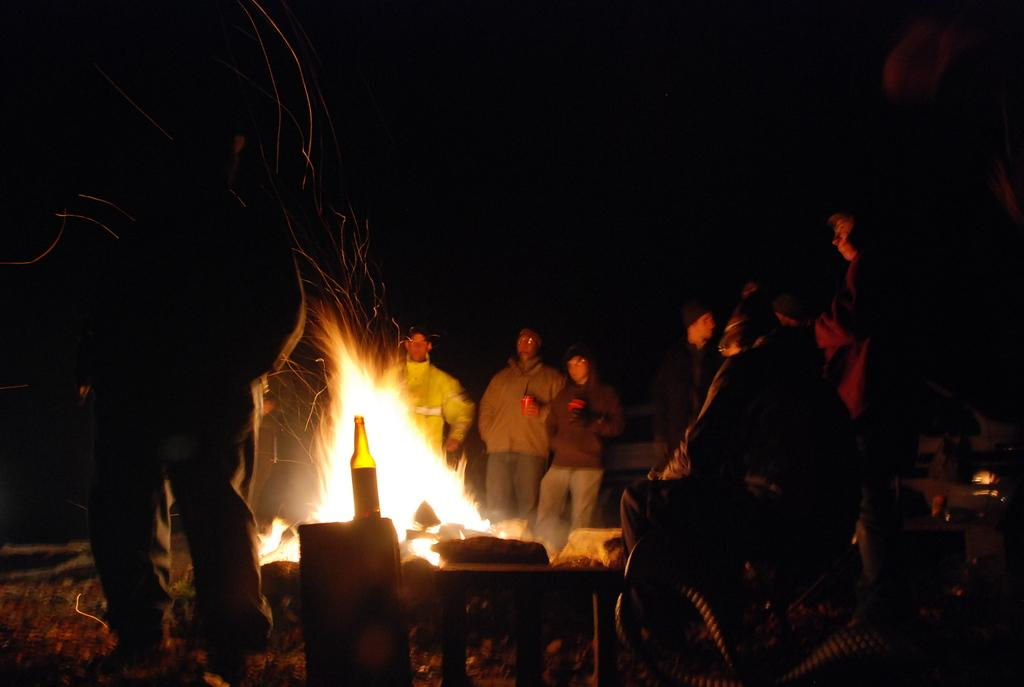What are the people in the image doing? There is a group of persons standing at the campfire in the image. What objects can be seen at the bottom of the image? There is a bottle and a table at the bottom of the image. What can be seen in the background of the image? The sky is visible in the background of the image. What news is being discussed by the group at the campfire? There is no indication in the image that the group is discussing any news. 